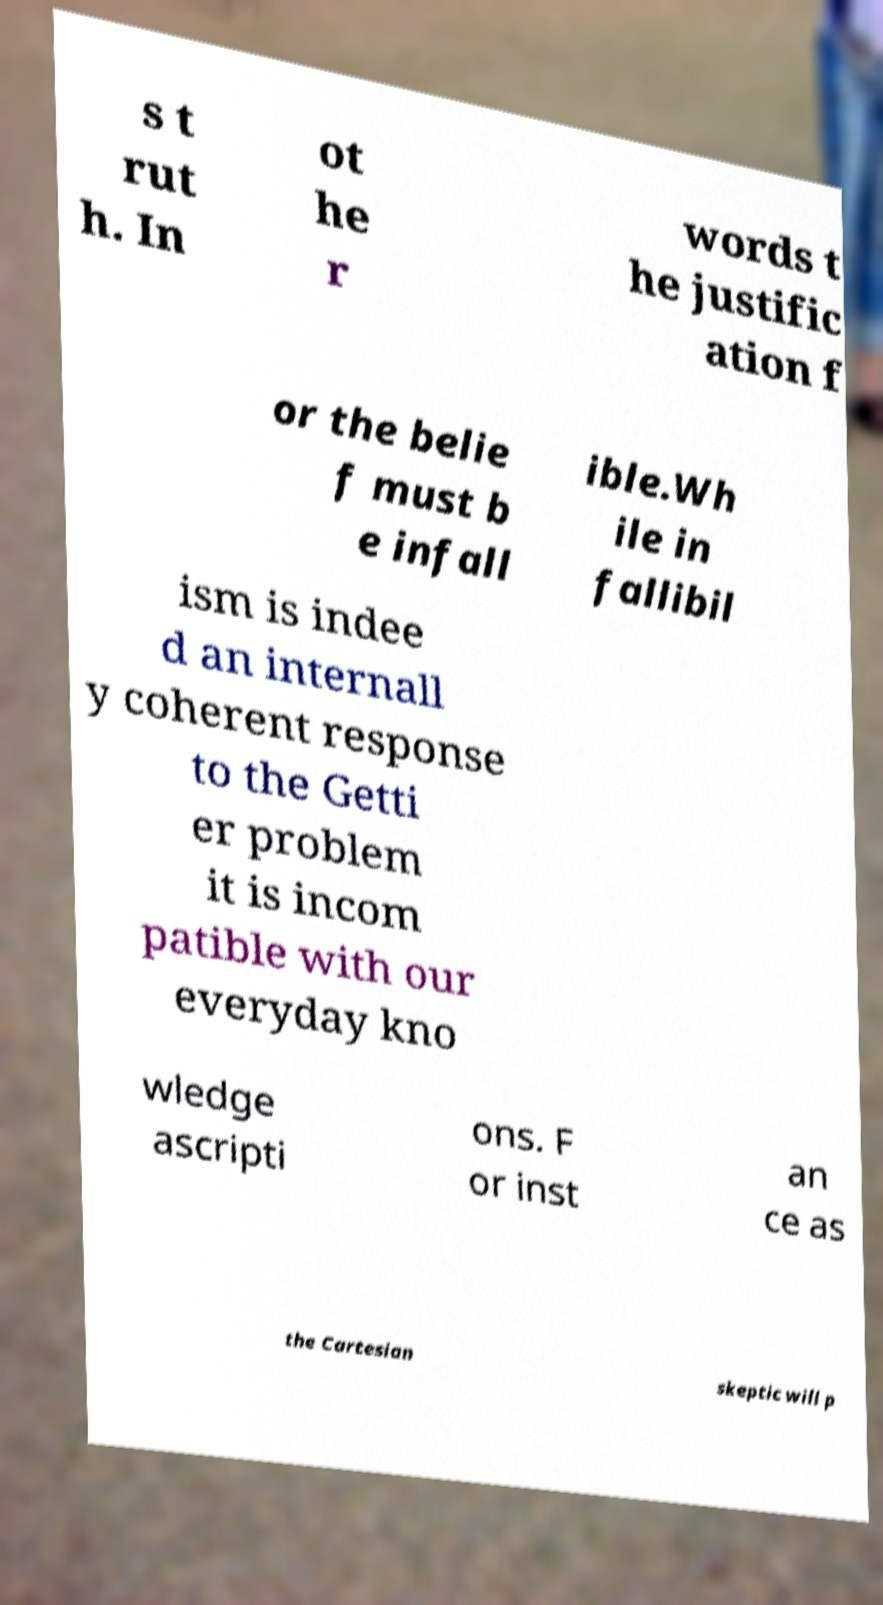Please identify and transcribe the text found in this image. s t rut h. In ot he r words t he justific ation f or the belie f must b e infall ible.Wh ile in fallibil ism is indee d an internall y coherent response to the Getti er problem it is incom patible with our everyday kno wledge ascripti ons. F or inst an ce as the Cartesian skeptic will p 